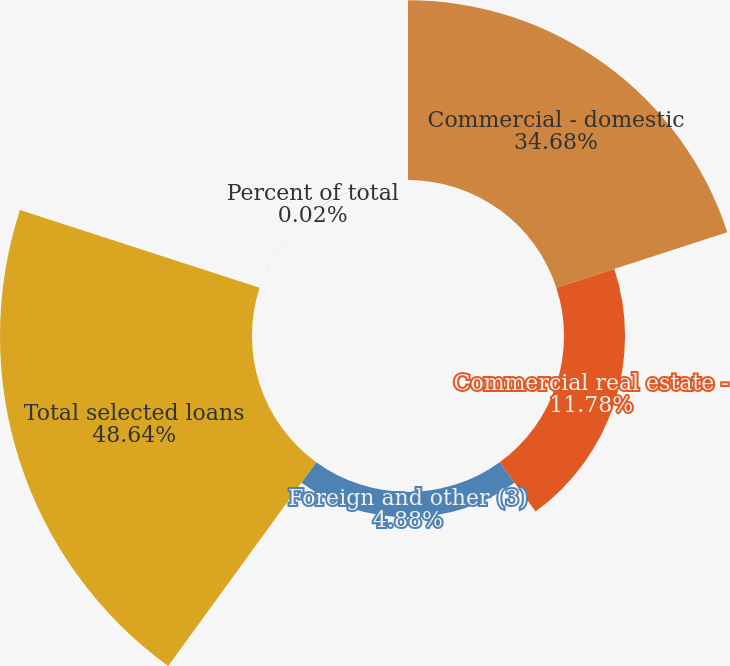<chart> <loc_0><loc_0><loc_500><loc_500><pie_chart><fcel>Commercial - domestic<fcel>Commercial real estate -<fcel>Foreign and other (3)<fcel>Total selected loans<fcel>Percent of total<nl><fcel>34.68%<fcel>11.78%<fcel>4.88%<fcel>48.64%<fcel>0.02%<nl></chart> 